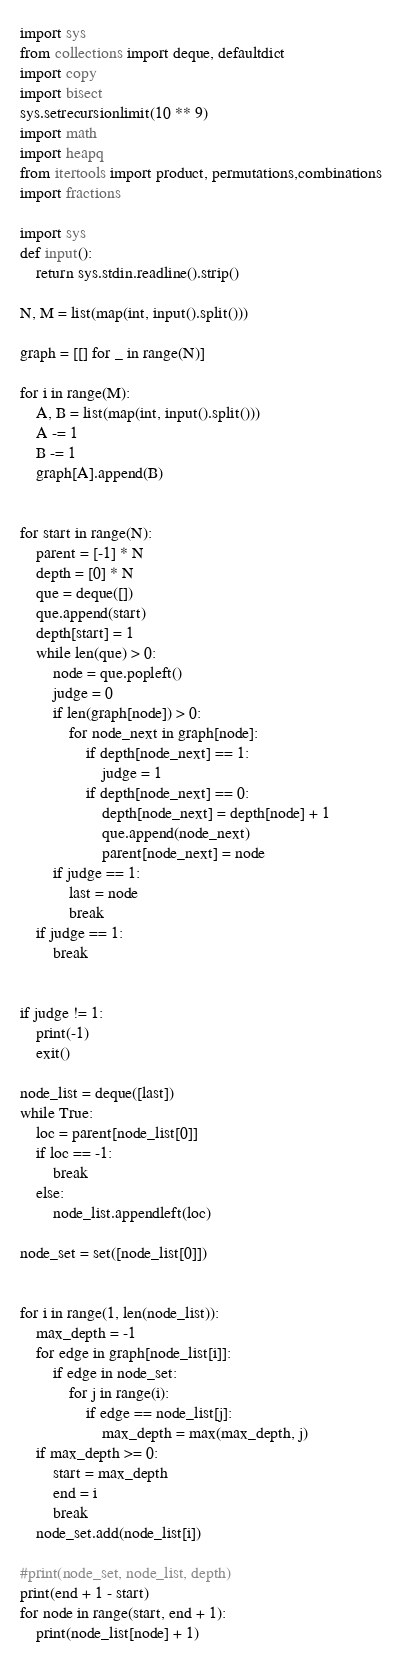<code> <loc_0><loc_0><loc_500><loc_500><_Python_>
import sys
from collections import deque, defaultdict
import copy
import bisect
sys.setrecursionlimit(10 ** 9)
import math
import heapq
from itertools import product, permutations,combinations
import fractions

import sys
def input():
	return sys.stdin.readline().strip()

N, M = list(map(int, input().split()))

graph = [[] for _ in range(N)]

for i in range(M):
	A, B = list(map(int, input().split()))
	A -= 1
	B -= 1
	graph[A].append(B)


for start in range(N):
	parent = [-1] * N
	depth = [0] * N
	que = deque([])
	que.append(start)
	depth[start] = 1
	while len(que) > 0:
		node = que.popleft()
		judge = 0
		if len(graph[node]) > 0:
			for node_next in graph[node]:
				if depth[node_next] == 1:
					judge = 1
				if depth[node_next] == 0:
					depth[node_next] = depth[node] + 1
					que.append(node_next)
					parent[node_next] = node
		if judge == 1:
			last = node
			break
	if judge == 1:
		break


if judge != 1:
	print(-1)
	exit()

node_list = deque([last])
while True:
	loc = parent[node_list[0]]
	if loc == -1:
		break
	else:
		node_list.appendleft(loc)

node_set = set([node_list[0]])


for i in range(1, len(node_list)):
	max_depth = -1
	for edge in graph[node_list[i]]:
		if edge in node_set:
			for j in range(i):
				if edge == node_list[j]:
					max_depth = max(max_depth, j)
	if max_depth >= 0:
		start = max_depth
		end = i
		break
	node_set.add(node_list[i])

#print(node_set, node_list, depth)
print(end + 1 - start)
for node in range(start, end + 1):
	print(node_list[node] + 1)</code> 